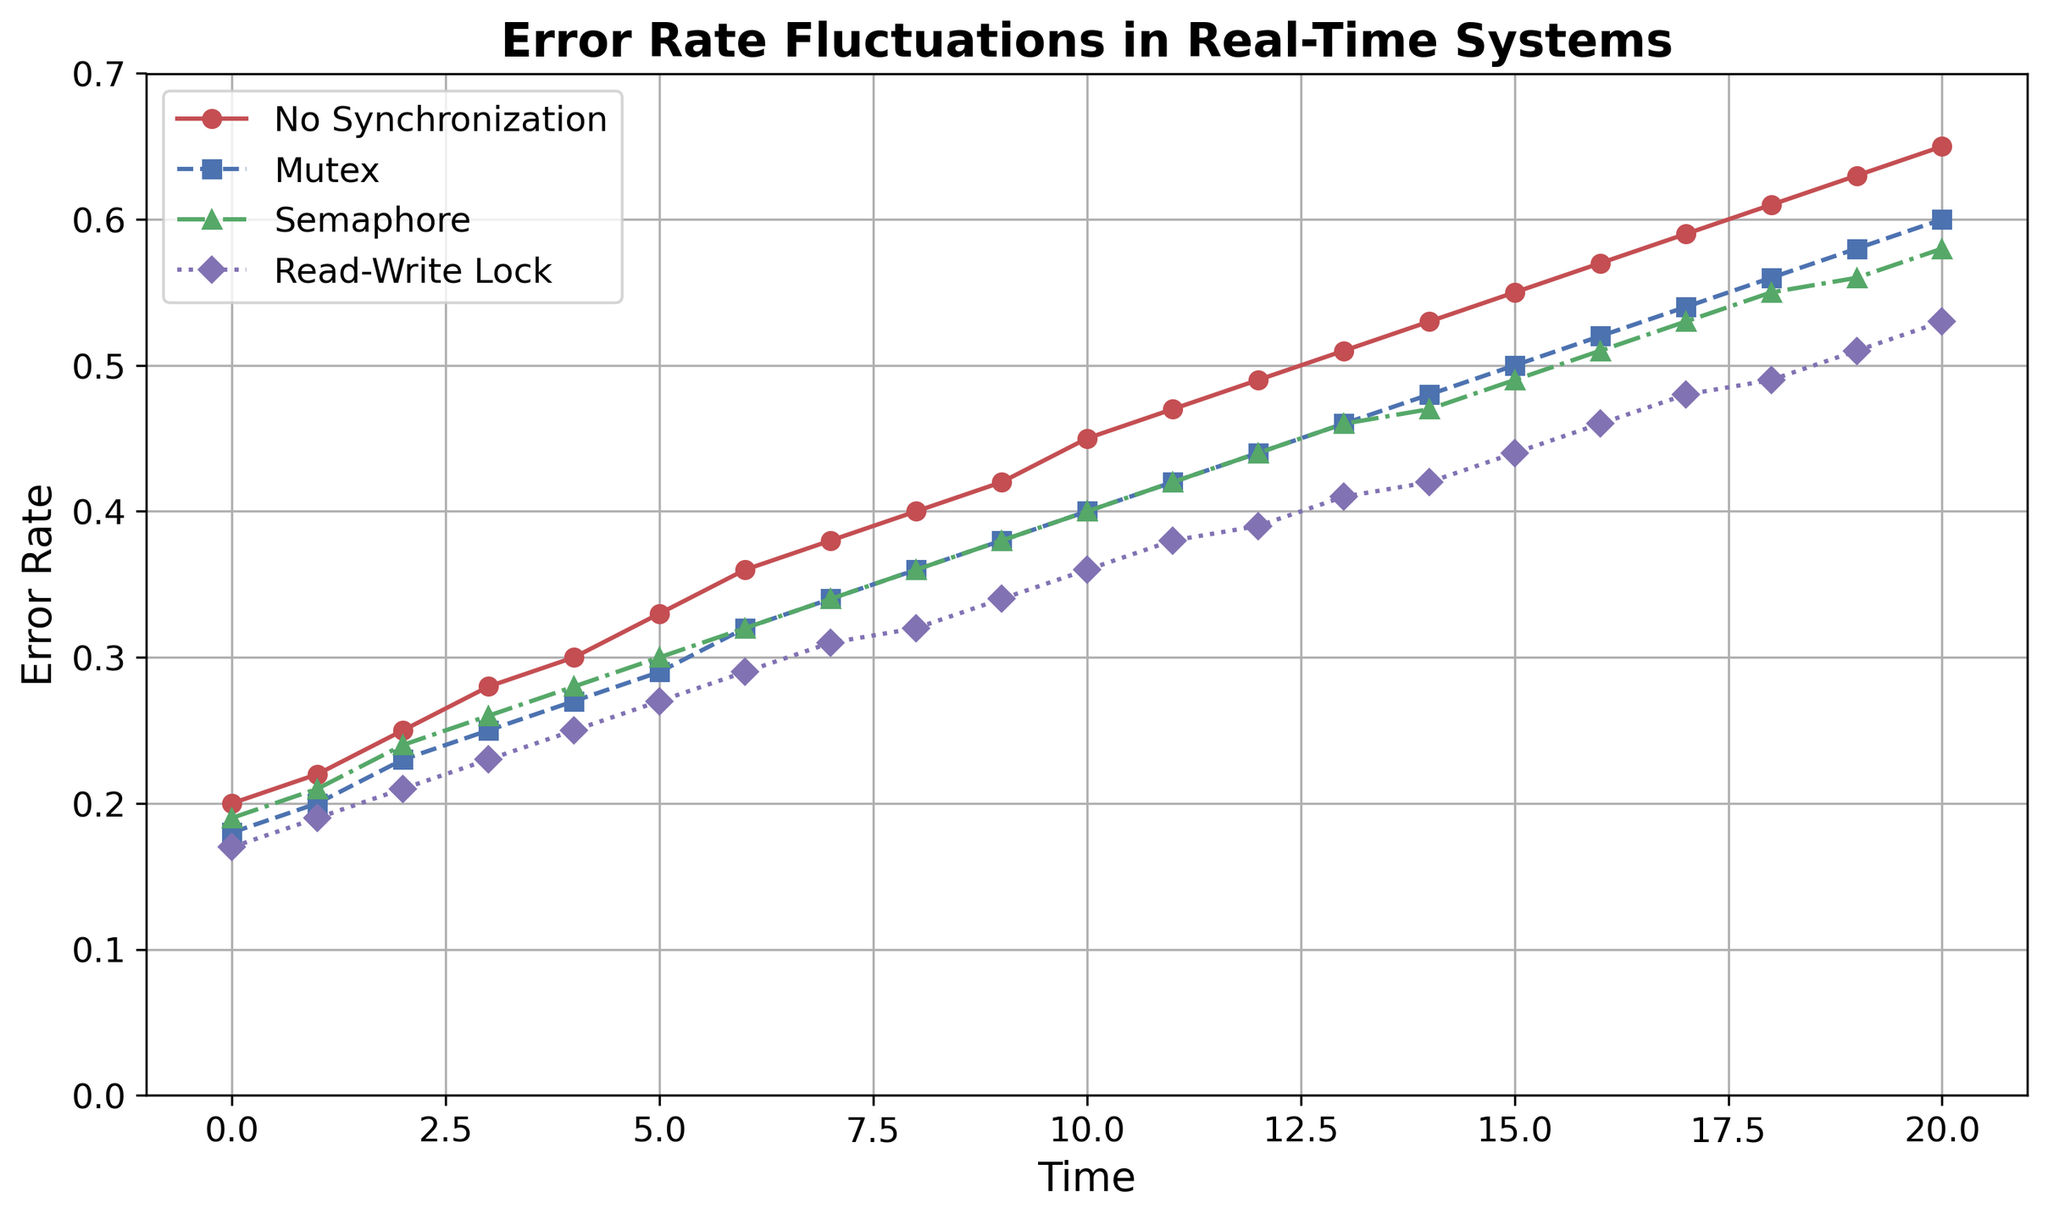What is the trend for the error rate with no synchronization over time? The line representing 'No Synchronization' is consistently increasing from the beginning to the end of the time period, showing an upward trend.
Answer: Upward trend How does the error rate for 'Mutex' at time 10 compare to 'Semaphore' at the same time? At time 10, the 'Mutex' error rate is at 0.40, while the 'Semaphore' error rate is also at 0.40. They are equal.
Answer: Equal Which synchronization mechanism has the lowest error rate at time 5? At time 5, 'Read-Write Lock' has an error rate of 0.27, which is the lowest compared to 'No Synchronization' (0.33), 'Mutex' (0.29), and 'Semaphore' (0.30).
Answer: Read-Write Lock What is the visual order of synchronization mechanisms from highest to lowest average error rate? Visually compare the lines; 'No Synchronization' has the highest, followed by 'Mutex', 'Semaphore', and 'Read-Write Lock' with the lowest error rate over time.
Answer: No Synchronization > Mutex > Semaphore > Read-Write Lock By how much does the error rate for 'No Synchronization' increase from time 0 to time 20? The error rate for 'No Synchronization' at time 0 is 0.20, and at time 20 it is 0.65. The increase is 0.65 - 0.20 = 0.45.
Answer: 0.45 Between time 10 and 15, which synchronization mechanism shows the steepest increase in error rate? Compare the slopes visually; 'No Synchronization' and 'Mutex' show a more steep rise compared to 'Semaphore' and 'Read-Write Lock', with 'No Synchronization' having the steepest.
Answer: No Synchronization At what time do 'Mutex' and 'Read-Write Lock' have approximately the same error rate? Visually, the 'Mutex' and 'Read-Write Lock' lines intersect around time 12 where their error rates are approximately 0.44.
Answer: Around time 12 Compute the difference in error rate between 'Semaphore' and 'Read-Write Lock' at time 20. At time 20, 'Semaphore' has an error rate of 0.58, and 'Read-Write Lock' has 0.53. The difference is 0.58 - 0.53 = 0.05.
Answer: 0.05 Which synchronization mechanism maintains the most consistent error rate over the entire period? Visually, 'Read-Write Lock' shows the least variation and smallest slope compared to others, indicating the most consistent error rate over time.
Answer: Read-Write Lock 